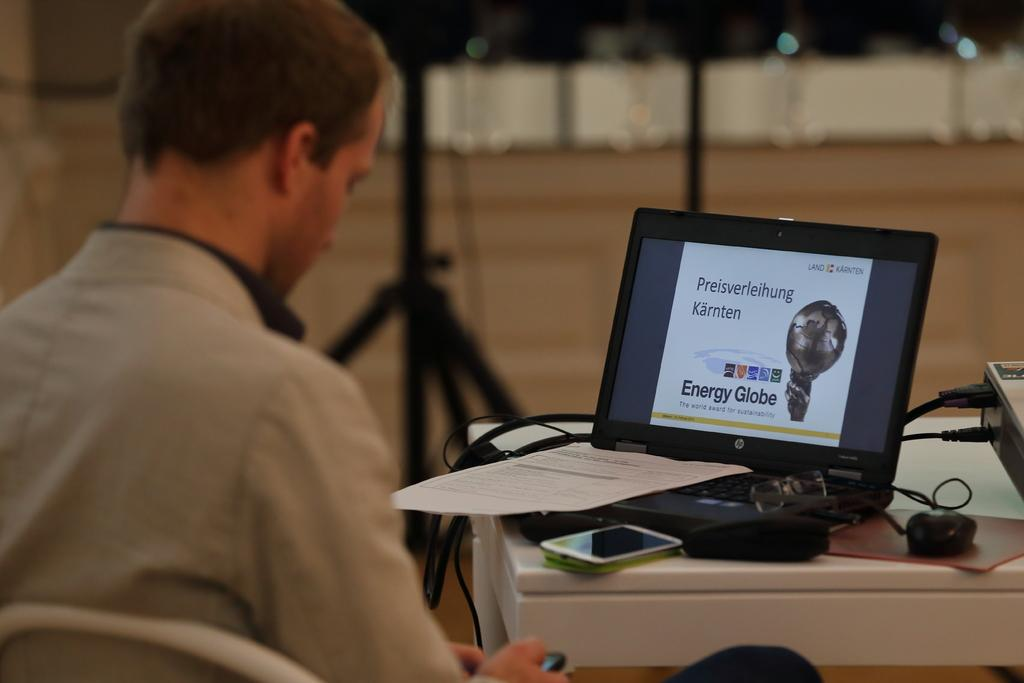What is the person in the image doing? The person is sitting on a chair. What is in front of the person? There is a table in front of the person. What objects can be seen on the table? There is a laptop, a paper, a mobile, a mouse, and a projector on the table. What else is visible in the image? There is a pole visible in the image. Where is the kitty playing with a bucket in the image? There is no kitty or bucket present in the image. What type of slip can be seen on the person's feet in the image? There is no mention of any footwear or slip in the provided facts, so it cannot be determined from the image. 